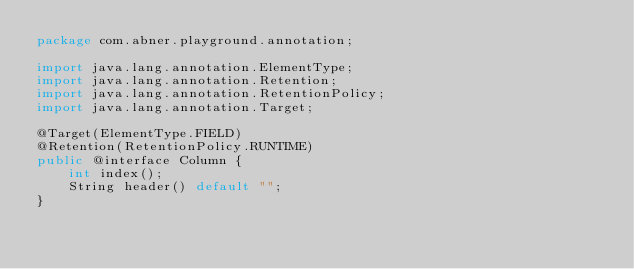<code> <loc_0><loc_0><loc_500><loc_500><_Java_>package com.abner.playground.annotation;

import java.lang.annotation.ElementType;
import java.lang.annotation.Retention;
import java.lang.annotation.RetentionPolicy;
import java.lang.annotation.Target;

@Target(ElementType.FIELD)
@Retention(RetentionPolicy.RUNTIME)
public @interface Column {
	int index();
	String header() default "";
}
</code> 